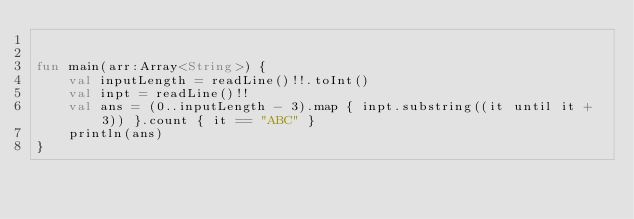Convert code to text. <code><loc_0><loc_0><loc_500><loc_500><_Kotlin_>

fun main(arr:Array<String>) {
    val inputLength = readLine()!!.toInt()
    val inpt = readLine()!!
    val ans = (0..inputLength - 3).map { inpt.substring((it until it + 3)) }.count { it == "ABC" }
    println(ans)
}


</code> 